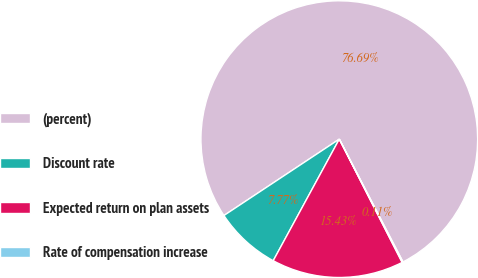<chart> <loc_0><loc_0><loc_500><loc_500><pie_chart><fcel>(percent)<fcel>Discount rate<fcel>Expected return on plan assets<fcel>Rate of compensation increase<nl><fcel>76.7%<fcel>7.77%<fcel>15.43%<fcel>0.11%<nl></chart> 